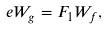<formula> <loc_0><loc_0><loc_500><loc_500>\ e W _ { g } = F _ { 1 } W _ { f } ,</formula> 